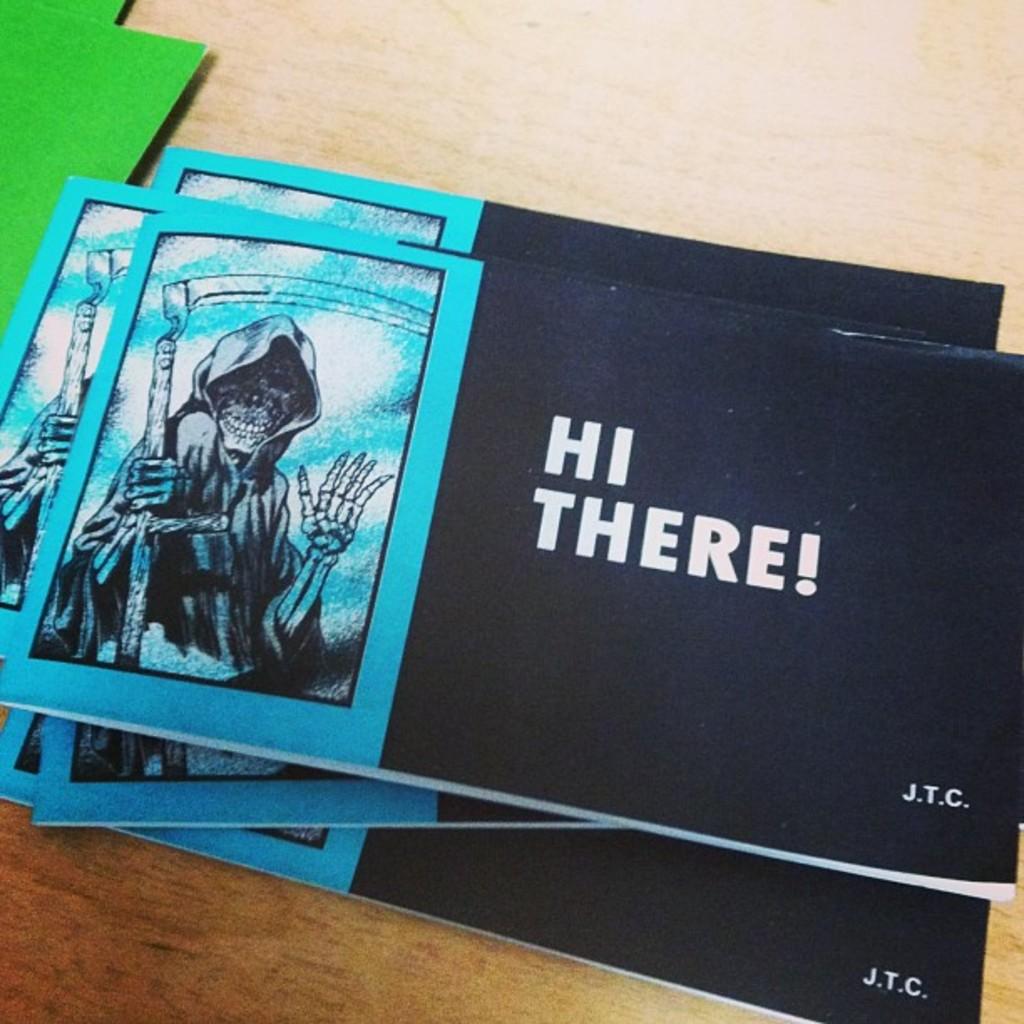What does the pamphlet say?
Give a very brief answer. Hi there!. What are the initials at the bottom right corner?
Make the answer very short. Jtc. 